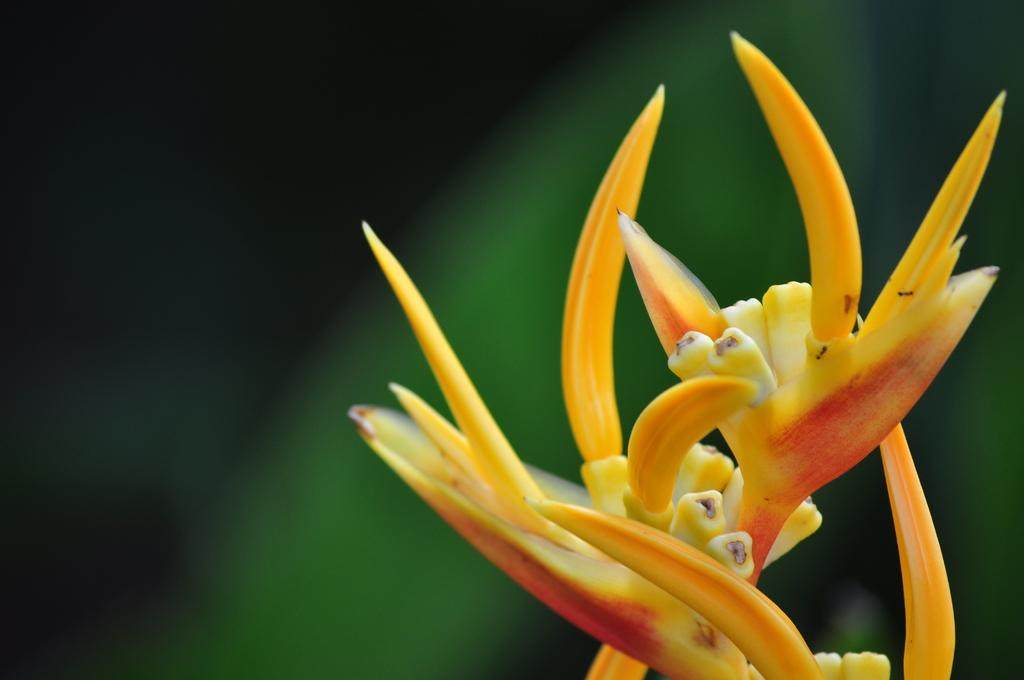What is the main subject of the image? There is a flower in the image. Can you describe the colors of the flower? The flower has yellow and red colors. How would you describe the background of the image? The background of the image is blurred. Is there a man surfing a wave in the background of the image? No, there is no man surfing a wave in the background of the image. The image only features a flower with a blurred background. 